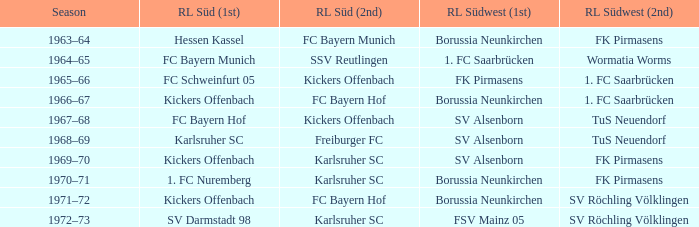Parse the table in full. {'header': ['Season', 'RL Süd (1st)', 'RL Süd (2nd)', 'RL Südwest (1st)', 'RL Südwest (2nd)'], 'rows': [['1963–64', 'Hessen Kassel', 'FC Bayern Munich', 'Borussia Neunkirchen', 'FK Pirmasens'], ['1964–65', 'FC Bayern Munich', 'SSV Reutlingen', '1. FC Saarbrücken', 'Wormatia Worms'], ['1965–66', 'FC Schweinfurt 05', 'Kickers Offenbach', 'FK Pirmasens', '1. FC Saarbrücken'], ['1966–67', 'Kickers Offenbach', 'FC Bayern Hof', 'Borussia Neunkirchen', '1. FC Saarbrücken'], ['1967–68', 'FC Bayern Hof', 'Kickers Offenbach', 'SV Alsenborn', 'TuS Neuendorf'], ['1968–69', 'Karlsruher SC', 'Freiburger FC', 'SV Alsenborn', 'TuS Neuendorf'], ['1969–70', 'Kickers Offenbach', 'Karlsruher SC', 'SV Alsenborn', 'FK Pirmasens'], ['1970–71', '1. FC Nuremberg', 'Karlsruher SC', 'Borussia Neunkirchen', 'FK Pirmasens'], ['1971–72', 'Kickers Offenbach', 'FC Bayern Hof', 'Borussia Neunkirchen', 'SV Röchling Völklingen'], ['1972–73', 'SV Darmstadt 98', 'Karlsruher SC', 'FSV Mainz 05', 'SV Röchling Völklingen']]} What season did SV Darmstadt 98 end up at RL Süd (1st)? 1972–73. 